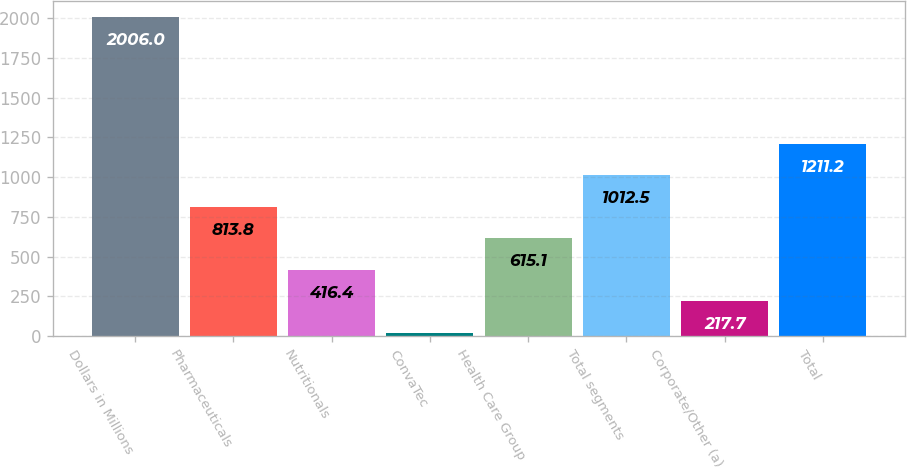<chart> <loc_0><loc_0><loc_500><loc_500><bar_chart><fcel>Dollars in Millions<fcel>Pharmaceuticals<fcel>Nutritionals<fcel>ConvaTec<fcel>Health Care Group<fcel>Total segments<fcel>Corporate/Other (a)<fcel>Total<nl><fcel>2006<fcel>813.8<fcel>416.4<fcel>19<fcel>615.1<fcel>1012.5<fcel>217.7<fcel>1211.2<nl></chart> 